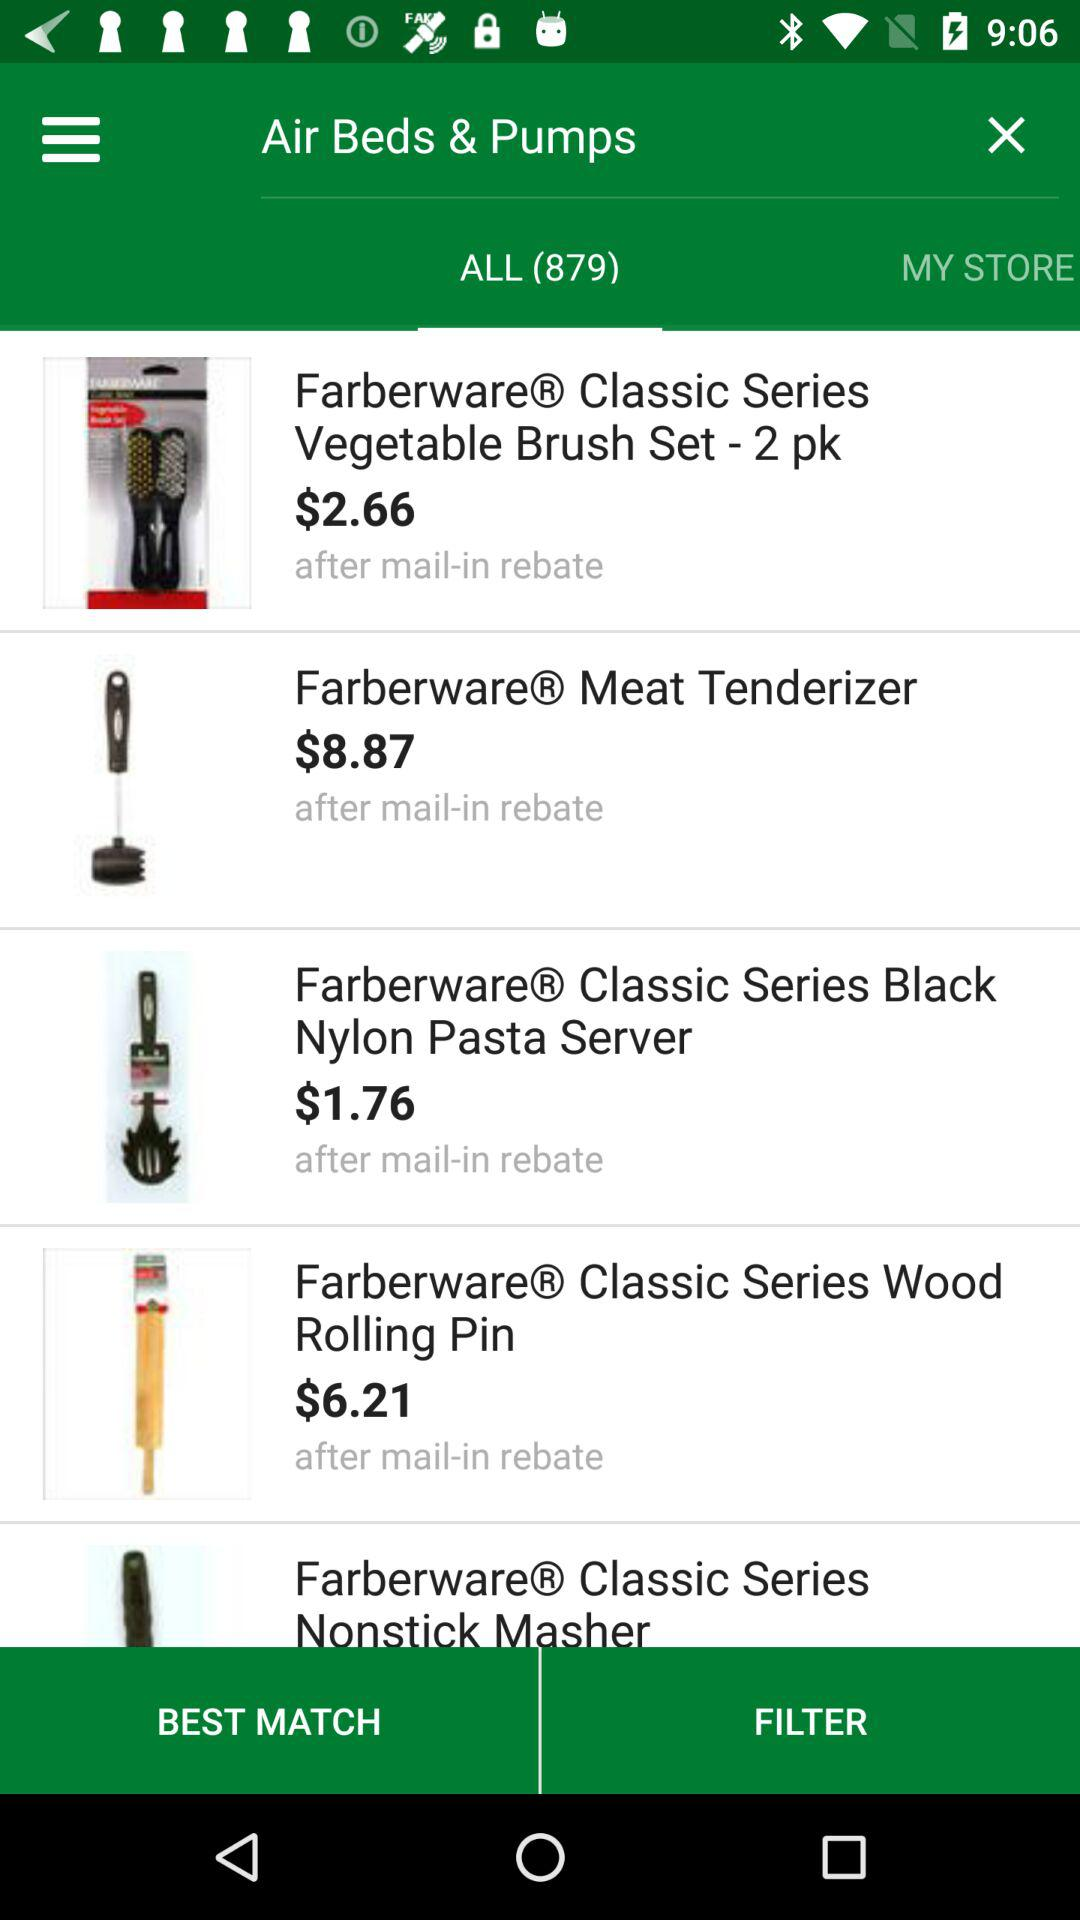How many items in total are there? There are 879 items in total. 